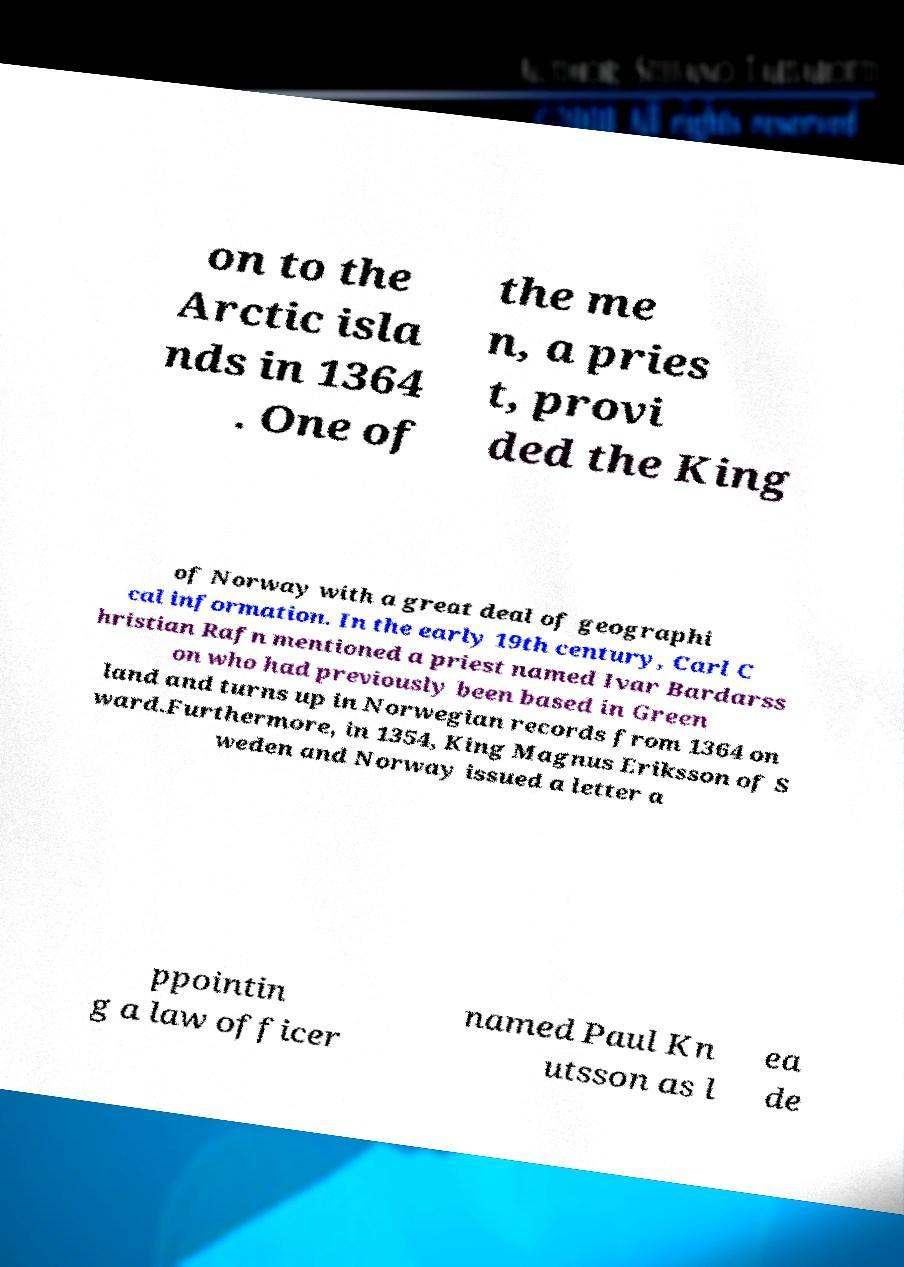What messages or text are displayed in this image? I need them in a readable, typed format. on to the Arctic isla nds in 1364 . One of the me n, a pries t, provi ded the King of Norway with a great deal of geographi cal information. In the early 19th century, Carl C hristian Rafn mentioned a priest named Ivar Bardarss on who had previously been based in Green land and turns up in Norwegian records from 1364 on ward.Furthermore, in 1354, King Magnus Eriksson of S weden and Norway issued a letter a ppointin g a law officer named Paul Kn utsson as l ea de 